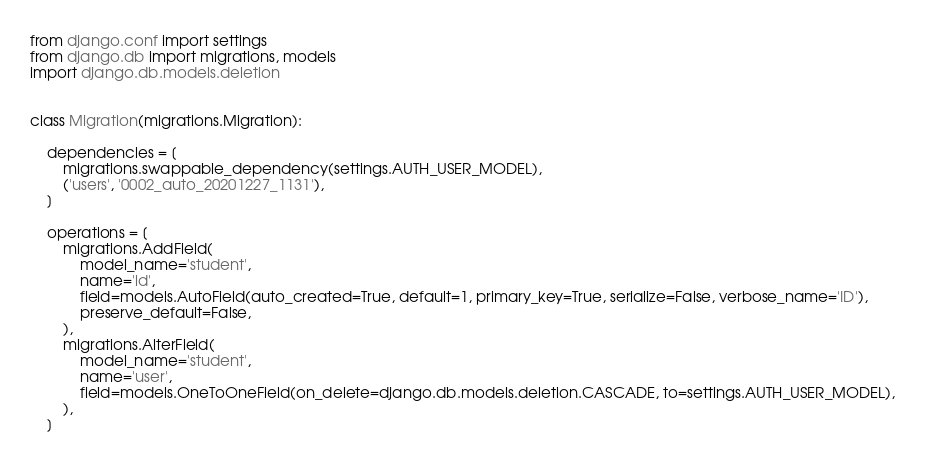<code> <loc_0><loc_0><loc_500><loc_500><_Python_>
from django.conf import settings
from django.db import migrations, models
import django.db.models.deletion


class Migration(migrations.Migration):

    dependencies = [
        migrations.swappable_dependency(settings.AUTH_USER_MODEL),
        ('users', '0002_auto_20201227_1131'),
    ]

    operations = [
        migrations.AddField(
            model_name='student',
            name='id',
            field=models.AutoField(auto_created=True, default=1, primary_key=True, serialize=False, verbose_name='ID'),
            preserve_default=False,
        ),
        migrations.AlterField(
            model_name='student',
            name='user',
            field=models.OneToOneField(on_delete=django.db.models.deletion.CASCADE, to=settings.AUTH_USER_MODEL),
        ),
    ]
</code> 